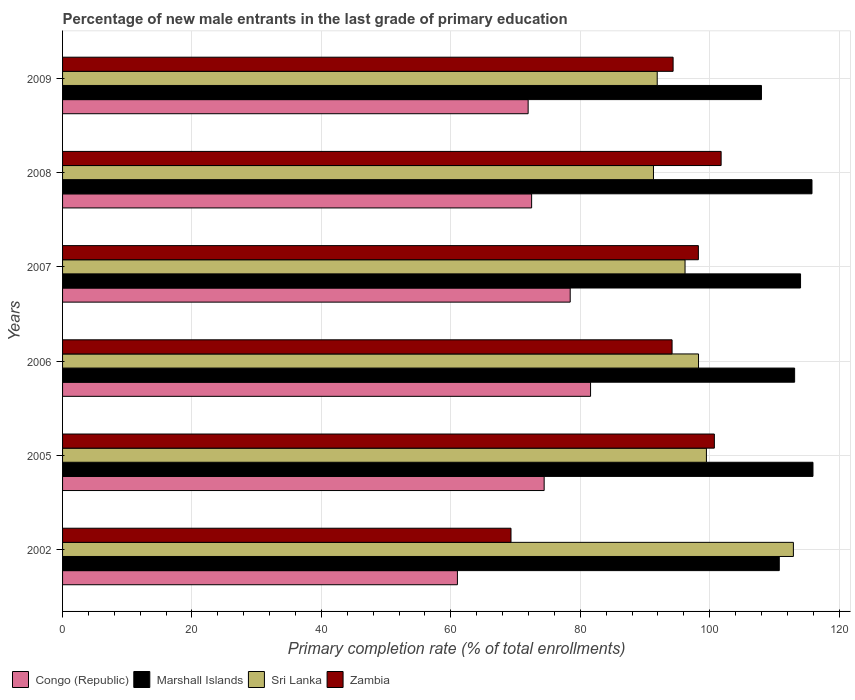How many different coloured bars are there?
Give a very brief answer. 4. Are the number of bars on each tick of the Y-axis equal?
Your response must be concise. Yes. How many bars are there on the 2nd tick from the bottom?
Make the answer very short. 4. In how many cases, is the number of bars for a given year not equal to the number of legend labels?
Your response must be concise. 0. What is the percentage of new male entrants in Zambia in 2009?
Your response must be concise. 94.35. Across all years, what is the maximum percentage of new male entrants in Congo (Republic)?
Offer a very short reply. 81.59. Across all years, what is the minimum percentage of new male entrants in Marshall Islands?
Make the answer very short. 108. In which year was the percentage of new male entrants in Zambia maximum?
Offer a terse response. 2008. In which year was the percentage of new male entrants in Sri Lanka minimum?
Your response must be concise. 2008. What is the total percentage of new male entrants in Sri Lanka in the graph?
Keep it short and to the point. 590.11. What is the difference between the percentage of new male entrants in Zambia in 2005 and that in 2007?
Keep it short and to the point. 2.47. What is the difference between the percentage of new male entrants in Marshall Islands in 2005 and the percentage of new male entrants in Zambia in 2008?
Make the answer very short. 14.19. What is the average percentage of new male entrants in Marshall Islands per year?
Keep it short and to the point. 112.95. In the year 2006, what is the difference between the percentage of new male entrants in Congo (Republic) and percentage of new male entrants in Sri Lanka?
Keep it short and to the point. -16.68. In how many years, is the percentage of new male entrants in Congo (Republic) greater than 116 %?
Your answer should be compact. 0. What is the ratio of the percentage of new male entrants in Congo (Republic) in 2005 to that in 2009?
Offer a very short reply. 1.03. What is the difference between the highest and the second highest percentage of new male entrants in Zambia?
Provide a succinct answer. 1.05. What is the difference between the highest and the lowest percentage of new male entrants in Zambia?
Your answer should be compact. 32.47. In how many years, is the percentage of new male entrants in Congo (Republic) greater than the average percentage of new male entrants in Congo (Republic) taken over all years?
Ensure brevity in your answer.  3. Is the sum of the percentage of new male entrants in Marshall Islands in 2002 and 2005 greater than the maximum percentage of new male entrants in Congo (Republic) across all years?
Give a very brief answer. Yes. What does the 3rd bar from the top in 2007 represents?
Your response must be concise. Marshall Islands. What does the 1st bar from the bottom in 2002 represents?
Make the answer very short. Congo (Republic). Is it the case that in every year, the sum of the percentage of new male entrants in Sri Lanka and percentage of new male entrants in Marshall Islands is greater than the percentage of new male entrants in Zambia?
Give a very brief answer. Yes. How many bars are there?
Provide a short and direct response. 24. How many years are there in the graph?
Give a very brief answer. 6. What is the difference between two consecutive major ticks on the X-axis?
Make the answer very short. 20. Are the values on the major ticks of X-axis written in scientific E-notation?
Your answer should be compact. No. Does the graph contain any zero values?
Provide a succinct answer. No. What is the title of the graph?
Give a very brief answer. Percentage of new male entrants in the last grade of primary education. What is the label or title of the X-axis?
Provide a short and direct response. Primary completion rate (% of total enrollments). What is the label or title of the Y-axis?
Make the answer very short. Years. What is the Primary completion rate (% of total enrollments) of Congo (Republic) in 2002?
Make the answer very short. 61.02. What is the Primary completion rate (% of total enrollments) of Marshall Islands in 2002?
Keep it short and to the point. 110.76. What is the Primary completion rate (% of total enrollments) of Sri Lanka in 2002?
Give a very brief answer. 112.94. What is the Primary completion rate (% of total enrollments) of Zambia in 2002?
Your answer should be compact. 69.3. What is the Primary completion rate (% of total enrollments) of Congo (Republic) in 2005?
Provide a short and direct response. 74.42. What is the Primary completion rate (% of total enrollments) in Marshall Islands in 2005?
Make the answer very short. 115.96. What is the Primary completion rate (% of total enrollments) of Sri Lanka in 2005?
Make the answer very short. 99.5. What is the Primary completion rate (% of total enrollments) in Zambia in 2005?
Provide a short and direct response. 100.72. What is the Primary completion rate (% of total enrollments) in Congo (Republic) in 2006?
Offer a very short reply. 81.59. What is the Primary completion rate (% of total enrollments) in Marshall Islands in 2006?
Your answer should be very brief. 113.13. What is the Primary completion rate (% of total enrollments) in Sri Lanka in 2006?
Keep it short and to the point. 98.27. What is the Primary completion rate (% of total enrollments) of Zambia in 2006?
Give a very brief answer. 94.19. What is the Primary completion rate (% of total enrollments) in Congo (Republic) in 2007?
Your response must be concise. 78.45. What is the Primary completion rate (% of total enrollments) of Marshall Islands in 2007?
Give a very brief answer. 114.04. What is the Primary completion rate (% of total enrollments) of Sri Lanka in 2007?
Provide a succinct answer. 96.19. What is the Primary completion rate (% of total enrollments) in Zambia in 2007?
Ensure brevity in your answer.  98.25. What is the Primary completion rate (% of total enrollments) of Congo (Republic) in 2008?
Provide a succinct answer. 72.48. What is the Primary completion rate (% of total enrollments) in Marshall Islands in 2008?
Give a very brief answer. 115.81. What is the Primary completion rate (% of total enrollments) of Sri Lanka in 2008?
Ensure brevity in your answer.  91.31. What is the Primary completion rate (% of total enrollments) of Zambia in 2008?
Offer a terse response. 101.77. What is the Primary completion rate (% of total enrollments) in Congo (Republic) in 2009?
Make the answer very short. 71.94. What is the Primary completion rate (% of total enrollments) of Marshall Islands in 2009?
Your response must be concise. 108. What is the Primary completion rate (% of total enrollments) in Sri Lanka in 2009?
Give a very brief answer. 91.89. What is the Primary completion rate (% of total enrollments) in Zambia in 2009?
Provide a succinct answer. 94.35. Across all years, what is the maximum Primary completion rate (% of total enrollments) of Congo (Republic)?
Provide a short and direct response. 81.59. Across all years, what is the maximum Primary completion rate (% of total enrollments) in Marshall Islands?
Ensure brevity in your answer.  115.96. Across all years, what is the maximum Primary completion rate (% of total enrollments) of Sri Lanka?
Your answer should be compact. 112.94. Across all years, what is the maximum Primary completion rate (% of total enrollments) in Zambia?
Offer a very short reply. 101.77. Across all years, what is the minimum Primary completion rate (% of total enrollments) in Congo (Republic)?
Your answer should be compact. 61.02. Across all years, what is the minimum Primary completion rate (% of total enrollments) of Marshall Islands?
Offer a terse response. 108. Across all years, what is the minimum Primary completion rate (% of total enrollments) of Sri Lanka?
Offer a very short reply. 91.31. Across all years, what is the minimum Primary completion rate (% of total enrollments) in Zambia?
Ensure brevity in your answer.  69.3. What is the total Primary completion rate (% of total enrollments) in Congo (Republic) in the graph?
Ensure brevity in your answer.  439.91. What is the total Primary completion rate (% of total enrollments) of Marshall Islands in the graph?
Make the answer very short. 677.7. What is the total Primary completion rate (% of total enrollments) in Sri Lanka in the graph?
Provide a succinct answer. 590.11. What is the total Primary completion rate (% of total enrollments) in Zambia in the graph?
Your answer should be compact. 558.58. What is the difference between the Primary completion rate (% of total enrollments) of Congo (Republic) in 2002 and that in 2005?
Your answer should be compact. -13.4. What is the difference between the Primary completion rate (% of total enrollments) of Marshall Islands in 2002 and that in 2005?
Keep it short and to the point. -5.21. What is the difference between the Primary completion rate (% of total enrollments) of Sri Lanka in 2002 and that in 2005?
Your answer should be very brief. 13.44. What is the difference between the Primary completion rate (% of total enrollments) of Zambia in 2002 and that in 2005?
Keep it short and to the point. -31.43. What is the difference between the Primary completion rate (% of total enrollments) in Congo (Republic) in 2002 and that in 2006?
Keep it short and to the point. -20.58. What is the difference between the Primary completion rate (% of total enrollments) in Marshall Islands in 2002 and that in 2006?
Keep it short and to the point. -2.37. What is the difference between the Primary completion rate (% of total enrollments) of Sri Lanka in 2002 and that in 2006?
Offer a very short reply. 14.66. What is the difference between the Primary completion rate (% of total enrollments) of Zambia in 2002 and that in 2006?
Provide a short and direct response. -24.89. What is the difference between the Primary completion rate (% of total enrollments) in Congo (Republic) in 2002 and that in 2007?
Your answer should be compact. -17.43. What is the difference between the Primary completion rate (% of total enrollments) of Marshall Islands in 2002 and that in 2007?
Your answer should be very brief. -3.29. What is the difference between the Primary completion rate (% of total enrollments) in Sri Lanka in 2002 and that in 2007?
Offer a terse response. 16.74. What is the difference between the Primary completion rate (% of total enrollments) in Zambia in 2002 and that in 2007?
Provide a succinct answer. -28.96. What is the difference between the Primary completion rate (% of total enrollments) of Congo (Republic) in 2002 and that in 2008?
Your answer should be compact. -11.47. What is the difference between the Primary completion rate (% of total enrollments) in Marshall Islands in 2002 and that in 2008?
Offer a very short reply. -5.05. What is the difference between the Primary completion rate (% of total enrollments) in Sri Lanka in 2002 and that in 2008?
Offer a very short reply. 21.62. What is the difference between the Primary completion rate (% of total enrollments) of Zambia in 2002 and that in 2008?
Keep it short and to the point. -32.47. What is the difference between the Primary completion rate (% of total enrollments) of Congo (Republic) in 2002 and that in 2009?
Offer a terse response. -10.93. What is the difference between the Primary completion rate (% of total enrollments) of Marshall Islands in 2002 and that in 2009?
Your response must be concise. 2.76. What is the difference between the Primary completion rate (% of total enrollments) of Sri Lanka in 2002 and that in 2009?
Ensure brevity in your answer.  21.04. What is the difference between the Primary completion rate (% of total enrollments) in Zambia in 2002 and that in 2009?
Provide a succinct answer. -25.05. What is the difference between the Primary completion rate (% of total enrollments) of Congo (Republic) in 2005 and that in 2006?
Offer a terse response. -7.17. What is the difference between the Primary completion rate (% of total enrollments) in Marshall Islands in 2005 and that in 2006?
Ensure brevity in your answer.  2.83. What is the difference between the Primary completion rate (% of total enrollments) in Sri Lanka in 2005 and that in 2006?
Provide a short and direct response. 1.22. What is the difference between the Primary completion rate (% of total enrollments) in Zambia in 2005 and that in 2006?
Your response must be concise. 6.54. What is the difference between the Primary completion rate (% of total enrollments) in Congo (Republic) in 2005 and that in 2007?
Offer a very short reply. -4.03. What is the difference between the Primary completion rate (% of total enrollments) of Marshall Islands in 2005 and that in 2007?
Provide a short and direct response. 1.92. What is the difference between the Primary completion rate (% of total enrollments) of Sri Lanka in 2005 and that in 2007?
Your response must be concise. 3.3. What is the difference between the Primary completion rate (% of total enrollments) of Zambia in 2005 and that in 2007?
Offer a terse response. 2.47. What is the difference between the Primary completion rate (% of total enrollments) of Congo (Republic) in 2005 and that in 2008?
Your answer should be very brief. 1.94. What is the difference between the Primary completion rate (% of total enrollments) in Marshall Islands in 2005 and that in 2008?
Your answer should be very brief. 0.15. What is the difference between the Primary completion rate (% of total enrollments) in Sri Lanka in 2005 and that in 2008?
Provide a short and direct response. 8.18. What is the difference between the Primary completion rate (% of total enrollments) in Zambia in 2005 and that in 2008?
Your answer should be compact. -1.05. What is the difference between the Primary completion rate (% of total enrollments) in Congo (Republic) in 2005 and that in 2009?
Provide a short and direct response. 2.48. What is the difference between the Primary completion rate (% of total enrollments) of Marshall Islands in 2005 and that in 2009?
Keep it short and to the point. 7.96. What is the difference between the Primary completion rate (% of total enrollments) in Sri Lanka in 2005 and that in 2009?
Make the answer very short. 7.6. What is the difference between the Primary completion rate (% of total enrollments) of Zambia in 2005 and that in 2009?
Provide a succinct answer. 6.38. What is the difference between the Primary completion rate (% of total enrollments) in Congo (Republic) in 2006 and that in 2007?
Offer a very short reply. 3.15. What is the difference between the Primary completion rate (% of total enrollments) in Marshall Islands in 2006 and that in 2007?
Your answer should be compact. -0.91. What is the difference between the Primary completion rate (% of total enrollments) in Sri Lanka in 2006 and that in 2007?
Give a very brief answer. 2.08. What is the difference between the Primary completion rate (% of total enrollments) of Zambia in 2006 and that in 2007?
Ensure brevity in your answer.  -4.07. What is the difference between the Primary completion rate (% of total enrollments) in Congo (Republic) in 2006 and that in 2008?
Give a very brief answer. 9.11. What is the difference between the Primary completion rate (% of total enrollments) in Marshall Islands in 2006 and that in 2008?
Provide a short and direct response. -2.68. What is the difference between the Primary completion rate (% of total enrollments) of Sri Lanka in 2006 and that in 2008?
Your answer should be compact. 6.96. What is the difference between the Primary completion rate (% of total enrollments) of Zambia in 2006 and that in 2008?
Provide a short and direct response. -7.58. What is the difference between the Primary completion rate (% of total enrollments) of Congo (Republic) in 2006 and that in 2009?
Your response must be concise. 9.65. What is the difference between the Primary completion rate (% of total enrollments) of Marshall Islands in 2006 and that in 2009?
Ensure brevity in your answer.  5.13. What is the difference between the Primary completion rate (% of total enrollments) of Sri Lanka in 2006 and that in 2009?
Give a very brief answer. 6.38. What is the difference between the Primary completion rate (% of total enrollments) of Zambia in 2006 and that in 2009?
Provide a succinct answer. -0.16. What is the difference between the Primary completion rate (% of total enrollments) in Congo (Republic) in 2007 and that in 2008?
Provide a succinct answer. 5.96. What is the difference between the Primary completion rate (% of total enrollments) of Marshall Islands in 2007 and that in 2008?
Offer a terse response. -1.77. What is the difference between the Primary completion rate (% of total enrollments) in Sri Lanka in 2007 and that in 2008?
Offer a terse response. 4.88. What is the difference between the Primary completion rate (% of total enrollments) in Zambia in 2007 and that in 2008?
Your response must be concise. -3.52. What is the difference between the Primary completion rate (% of total enrollments) of Congo (Republic) in 2007 and that in 2009?
Ensure brevity in your answer.  6.5. What is the difference between the Primary completion rate (% of total enrollments) in Marshall Islands in 2007 and that in 2009?
Your answer should be very brief. 6.04. What is the difference between the Primary completion rate (% of total enrollments) of Sri Lanka in 2007 and that in 2009?
Offer a terse response. 4.3. What is the difference between the Primary completion rate (% of total enrollments) in Zambia in 2007 and that in 2009?
Your response must be concise. 3.91. What is the difference between the Primary completion rate (% of total enrollments) of Congo (Republic) in 2008 and that in 2009?
Give a very brief answer. 0.54. What is the difference between the Primary completion rate (% of total enrollments) in Marshall Islands in 2008 and that in 2009?
Your response must be concise. 7.81. What is the difference between the Primary completion rate (% of total enrollments) in Sri Lanka in 2008 and that in 2009?
Your answer should be compact. -0.58. What is the difference between the Primary completion rate (% of total enrollments) of Zambia in 2008 and that in 2009?
Your answer should be very brief. 7.42. What is the difference between the Primary completion rate (% of total enrollments) of Congo (Republic) in 2002 and the Primary completion rate (% of total enrollments) of Marshall Islands in 2005?
Your response must be concise. -54.94. What is the difference between the Primary completion rate (% of total enrollments) in Congo (Republic) in 2002 and the Primary completion rate (% of total enrollments) in Sri Lanka in 2005?
Provide a short and direct response. -38.48. What is the difference between the Primary completion rate (% of total enrollments) in Congo (Republic) in 2002 and the Primary completion rate (% of total enrollments) in Zambia in 2005?
Give a very brief answer. -39.71. What is the difference between the Primary completion rate (% of total enrollments) in Marshall Islands in 2002 and the Primary completion rate (% of total enrollments) in Sri Lanka in 2005?
Make the answer very short. 11.26. What is the difference between the Primary completion rate (% of total enrollments) in Marshall Islands in 2002 and the Primary completion rate (% of total enrollments) in Zambia in 2005?
Ensure brevity in your answer.  10.03. What is the difference between the Primary completion rate (% of total enrollments) in Sri Lanka in 2002 and the Primary completion rate (% of total enrollments) in Zambia in 2005?
Your response must be concise. 12.21. What is the difference between the Primary completion rate (% of total enrollments) in Congo (Republic) in 2002 and the Primary completion rate (% of total enrollments) in Marshall Islands in 2006?
Your response must be concise. -52.11. What is the difference between the Primary completion rate (% of total enrollments) in Congo (Republic) in 2002 and the Primary completion rate (% of total enrollments) in Sri Lanka in 2006?
Ensure brevity in your answer.  -37.26. What is the difference between the Primary completion rate (% of total enrollments) of Congo (Republic) in 2002 and the Primary completion rate (% of total enrollments) of Zambia in 2006?
Keep it short and to the point. -33.17. What is the difference between the Primary completion rate (% of total enrollments) in Marshall Islands in 2002 and the Primary completion rate (% of total enrollments) in Sri Lanka in 2006?
Ensure brevity in your answer.  12.48. What is the difference between the Primary completion rate (% of total enrollments) of Marshall Islands in 2002 and the Primary completion rate (% of total enrollments) of Zambia in 2006?
Your answer should be very brief. 16.57. What is the difference between the Primary completion rate (% of total enrollments) in Sri Lanka in 2002 and the Primary completion rate (% of total enrollments) in Zambia in 2006?
Your answer should be very brief. 18.75. What is the difference between the Primary completion rate (% of total enrollments) in Congo (Republic) in 2002 and the Primary completion rate (% of total enrollments) in Marshall Islands in 2007?
Ensure brevity in your answer.  -53.02. What is the difference between the Primary completion rate (% of total enrollments) of Congo (Republic) in 2002 and the Primary completion rate (% of total enrollments) of Sri Lanka in 2007?
Your answer should be very brief. -35.18. What is the difference between the Primary completion rate (% of total enrollments) of Congo (Republic) in 2002 and the Primary completion rate (% of total enrollments) of Zambia in 2007?
Offer a very short reply. -37.24. What is the difference between the Primary completion rate (% of total enrollments) in Marshall Islands in 2002 and the Primary completion rate (% of total enrollments) in Sri Lanka in 2007?
Your response must be concise. 14.56. What is the difference between the Primary completion rate (% of total enrollments) of Marshall Islands in 2002 and the Primary completion rate (% of total enrollments) of Zambia in 2007?
Give a very brief answer. 12.5. What is the difference between the Primary completion rate (% of total enrollments) in Sri Lanka in 2002 and the Primary completion rate (% of total enrollments) in Zambia in 2007?
Make the answer very short. 14.68. What is the difference between the Primary completion rate (% of total enrollments) of Congo (Republic) in 2002 and the Primary completion rate (% of total enrollments) of Marshall Islands in 2008?
Your answer should be compact. -54.79. What is the difference between the Primary completion rate (% of total enrollments) of Congo (Republic) in 2002 and the Primary completion rate (% of total enrollments) of Sri Lanka in 2008?
Ensure brevity in your answer.  -30.3. What is the difference between the Primary completion rate (% of total enrollments) in Congo (Republic) in 2002 and the Primary completion rate (% of total enrollments) in Zambia in 2008?
Keep it short and to the point. -40.75. What is the difference between the Primary completion rate (% of total enrollments) of Marshall Islands in 2002 and the Primary completion rate (% of total enrollments) of Sri Lanka in 2008?
Make the answer very short. 19.44. What is the difference between the Primary completion rate (% of total enrollments) in Marshall Islands in 2002 and the Primary completion rate (% of total enrollments) in Zambia in 2008?
Provide a short and direct response. 8.99. What is the difference between the Primary completion rate (% of total enrollments) of Sri Lanka in 2002 and the Primary completion rate (% of total enrollments) of Zambia in 2008?
Provide a succinct answer. 11.17. What is the difference between the Primary completion rate (% of total enrollments) of Congo (Republic) in 2002 and the Primary completion rate (% of total enrollments) of Marshall Islands in 2009?
Your response must be concise. -46.98. What is the difference between the Primary completion rate (% of total enrollments) in Congo (Republic) in 2002 and the Primary completion rate (% of total enrollments) in Sri Lanka in 2009?
Your answer should be compact. -30.88. What is the difference between the Primary completion rate (% of total enrollments) in Congo (Republic) in 2002 and the Primary completion rate (% of total enrollments) in Zambia in 2009?
Give a very brief answer. -33.33. What is the difference between the Primary completion rate (% of total enrollments) in Marshall Islands in 2002 and the Primary completion rate (% of total enrollments) in Sri Lanka in 2009?
Make the answer very short. 18.86. What is the difference between the Primary completion rate (% of total enrollments) in Marshall Islands in 2002 and the Primary completion rate (% of total enrollments) in Zambia in 2009?
Keep it short and to the point. 16.41. What is the difference between the Primary completion rate (% of total enrollments) of Sri Lanka in 2002 and the Primary completion rate (% of total enrollments) of Zambia in 2009?
Provide a short and direct response. 18.59. What is the difference between the Primary completion rate (% of total enrollments) of Congo (Republic) in 2005 and the Primary completion rate (% of total enrollments) of Marshall Islands in 2006?
Offer a terse response. -38.71. What is the difference between the Primary completion rate (% of total enrollments) in Congo (Republic) in 2005 and the Primary completion rate (% of total enrollments) in Sri Lanka in 2006?
Provide a succinct answer. -23.85. What is the difference between the Primary completion rate (% of total enrollments) in Congo (Republic) in 2005 and the Primary completion rate (% of total enrollments) in Zambia in 2006?
Give a very brief answer. -19.77. What is the difference between the Primary completion rate (% of total enrollments) of Marshall Islands in 2005 and the Primary completion rate (% of total enrollments) of Sri Lanka in 2006?
Your answer should be very brief. 17.69. What is the difference between the Primary completion rate (% of total enrollments) in Marshall Islands in 2005 and the Primary completion rate (% of total enrollments) in Zambia in 2006?
Make the answer very short. 21.77. What is the difference between the Primary completion rate (% of total enrollments) in Sri Lanka in 2005 and the Primary completion rate (% of total enrollments) in Zambia in 2006?
Your answer should be compact. 5.31. What is the difference between the Primary completion rate (% of total enrollments) of Congo (Republic) in 2005 and the Primary completion rate (% of total enrollments) of Marshall Islands in 2007?
Offer a very short reply. -39.62. What is the difference between the Primary completion rate (% of total enrollments) of Congo (Republic) in 2005 and the Primary completion rate (% of total enrollments) of Sri Lanka in 2007?
Offer a very short reply. -21.77. What is the difference between the Primary completion rate (% of total enrollments) in Congo (Republic) in 2005 and the Primary completion rate (% of total enrollments) in Zambia in 2007?
Your answer should be very brief. -23.83. What is the difference between the Primary completion rate (% of total enrollments) in Marshall Islands in 2005 and the Primary completion rate (% of total enrollments) in Sri Lanka in 2007?
Keep it short and to the point. 19.77. What is the difference between the Primary completion rate (% of total enrollments) of Marshall Islands in 2005 and the Primary completion rate (% of total enrollments) of Zambia in 2007?
Your answer should be compact. 17.71. What is the difference between the Primary completion rate (% of total enrollments) of Sri Lanka in 2005 and the Primary completion rate (% of total enrollments) of Zambia in 2007?
Keep it short and to the point. 1.24. What is the difference between the Primary completion rate (% of total enrollments) of Congo (Republic) in 2005 and the Primary completion rate (% of total enrollments) of Marshall Islands in 2008?
Provide a short and direct response. -41.39. What is the difference between the Primary completion rate (% of total enrollments) of Congo (Republic) in 2005 and the Primary completion rate (% of total enrollments) of Sri Lanka in 2008?
Provide a short and direct response. -16.89. What is the difference between the Primary completion rate (% of total enrollments) in Congo (Republic) in 2005 and the Primary completion rate (% of total enrollments) in Zambia in 2008?
Make the answer very short. -27.35. What is the difference between the Primary completion rate (% of total enrollments) in Marshall Islands in 2005 and the Primary completion rate (% of total enrollments) in Sri Lanka in 2008?
Your answer should be compact. 24.65. What is the difference between the Primary completion rate (% of total enrollments) of Marshall Islands in 2005 and the Primary completion rate (% of total enrollments) of Zambia in 2008?
Your response must be concise. 14.19. What is the difference between the Primary completion rate (% of total enrollments) of Sri Lanka in 2005 and the Primary completion rate (% of total enrollments) of Zambia in 2008?
Keep it short and to the point. -2.27. What is the difference between the Primary completion rate (% of total enrollments) of Congo (Republic) in 2005 and the Primary completion rate (% of total enrollments) of Marshall Islands in 2009?
Offer a terse response. -33.58. What is the difference between the Primary completion rate (% of total enrollments) of Congo (Republic) in 2005 and the Primary completion rate (% of total enrollments) of Sri Lanka in 2009?
Provide a succinct answer. -17.47. What is the difference between the Primary completion rate (% of total enrollments) in Congo (Republic) in 2005 and the Primary completion rate (% of total enrollments) in Zambia in 2009?
Offer a terse response. -19.93. What is the difference between the Primary completion rate (% of total enrollments) in Marshall Islands in 2005 and the Primary completion rate (% of total enrollments) in Sri Lanka in 2009?
Ensure brevity in your answer.  24.07. What is the difference between the Primary completion rate (% of total enrollments) in Marshall Islands in 2005 and the Primary completion rate (% of total enrollments) in Zambia in 2009?
Ensure brevity in your answer.  21.61. What is the difference between the Primary completion rate (% of total enrollments) in Sri Lanka in 2005 and the Primary completion rate (% of total enrollments) in Zambia in 2009?
Give a very brief answer. 5.15. What is the difference between the Primary completion rate (% of total enrollments) of Congo (Republic) in 2006 and the Primary completion rate (% of total enrollments) of Marshall Islands in 2007?
Provide a succinct answer. -32.45. What is the difference between the Primary completion rate (% of total enrollments) of Congo (Republic) in 2006 and the Primary completion rate (% of total enrollments) of Sri Lanka in 2007?
Make the answer very short. -14.6. What is the difference between the Primary completion rate (% of total enrollments) in Congo (Republic) in 2006 and the Primary completion rate (% of total enrollments) in Zambia in 2007?
Ensure brevity in your answer.  -16.66. What is the difference between the Primary completion rate (% of total enrollments) of Marshall Islands in 2006 and the Primary completion rate (% of total enrollments) of Sri Lanka in 2007?
Provide a short and direct response. 16.93. What is the difference between the Primary completion rate (% of total enrollments) of Marshall Islands in 2006 and the Primary completion rate (% of total enrollments) of Zambia in 2007?
Offer a terse response. 14.87. What is the difference between the Primary completion rate (% of total enrollments) of Sri Lanka in 2006 and the Primary completion rate (% of total enrollments) of Zambia in 2007?
Make the answer very short. 0.02. What is the difference between the Primary completion rate (% of total enrollments) of Congo (Republic) in 2006 and the Primary completion rate (% of total enrollments) of Marshall Islands in 2008?
Ensure brevity in your answer.  -34.22. What is the difference between the Primary completion rate (% of total enrollments) in Congo (Republic) in 2006 and the Primary completion rate (% of total enrollments) in Sri Lanka in 2008?
Provide a succinct answer. -9.72. What is the difference between the Primary completion rate (% of total enrollments) of Congo (Republic) in 2006 and the Primary completion rate (% of total enrollments) of Zambia in 2008?
Provide a succinct answer. -20.18. What is the difference between the Primary completion rate (% of total enrollments) of Marshall Islands in 2006 and the Primary completion rate (% of total enrollments) of Sri Lanka in 2008?
Your answer should be compact. 21.81. What is the difference between the Primary completion rate (% of total enrollments) in Marshall Islands in 2006 and the Primary completion rate (% of total enrollments) in Zambia in 2008?
Provide a short and direct response. 11.36. What is the difference between the Primary completion rate (% of total enrollments) of Sri Lanka in 2006 and the Primary completion rate (% of total enrollments) of Zambia in 2008?
Your answer should be very brief. -3.49. What is the difference between the Primary completion rate (% of total enrollments) in Congo (Republic) in 2006 and the Primary completion rate (% of total enrollments) in Marshall Islands in 2009?
Offer a terse response. -26.41. What is the difference between the Primary completion rate (% of total enrollments) in Congo (Republic) in 2006 and the Primary completion rate (% of total enrollments) in Sri Lanka in 2009?
Offer a very short reply. -10.3. What is the difference between the Primary completion rate (% of total enrollments) of Congo (Republic) in 2006 and the Primary completion rate (% of total enrollments) of Zambia in 2009?
Offer a very short reply. -12.76. What is the difference between the Primary completion rate (% of total enrollments) in Marshall Islands in 2006 and the Primary completion rate (% of total enrollments) in Sri Lanka in 2009?
Make the answer very short. 21.23. What is the difference between the Primary completion rate (% of total enrollments) of Marshall Islands in 2006 and the Primary completion rate (% of total enrollments) of Zambia in 2009?
Provide a short and direct response. 18.78. What is the difference between the Primary completion rate (% of total enrollments) in Sri Lanka in 2006 and the Primary completion rate (% of total enrollments) in Zambia in 2009?
Ensure brevity in your answer.  3.93. What is the difference between the Primary completion rate (% of total enrollments) of Congo (Republic) in 2007 and the Primary completion rate (% of total enrollments) of Marshall Islands in 2008?
Your answer should be very brief. -37.36. What is the difference between the Primary completion rate (% of total enrollments) of Congo (Republic) in 2007 and the Primary completion rate (% of total enrollments) of Sri Lanka in 2008?
Keep it short and to the point. -12.87. What is the difference between the Primary completion rate (% of total enrollments) of Congo (Republic) in 2007 and the Primary completion rate (% of total enrollments) of Zambia in 2008?
Provide a succinct answer. -23.32. What is the difference between the Primary completion rate (% of total enrollments) of Marshall Islands in 2007 and the Primary completion rate (% of total enrollments) of Sri Lanka in 2008?
Provide a succinct answer. 22.73. What is the difference between the Primary completion rate (% of total enrollments) of Marshall Islands in 2007 and the Primary completion rate (% of total enrollments) of Zambia in 2008?
Ensure brevity in your answer.  12.27. What is the difference between the Primary completion rate (% of total enrollments) of Sri Lanka in 2007 and the Primary completion rate (% of total enrollments) of Zambia in 2008?
Keep it short and to the point. -5.58. What is the difference between the Primary completion rate (% of total enrollments) in Congo (Republic) in 2007 and the Primary completion rate (% of total enrollments) in Marshall Islands in 2009?
Make the answer very short. -29.55. What is the difference between the Primary completion rate (% of total enrollments) of Congo (Republic) in 2007 and the Primary completion rate (% of total enrollments) of Sri Lanka in 2009?
Your answer should be compact. -13.45. What is the difference between the Primary completion rate (% of total enrollments) of Congo (Republic) in 2007 and the Primary completion rate (% of total enrollments) of Zambia in 2009?
Give a very brief answer. -15.9. What is the difference between the Primary completion rate (% of total enrollments) in Marshall Islands in 2007 and the Primary completion rate (% of total enrollments) in Sri Lanka in 2009?
Your answer should be compact. 22.15. What is the difference between the Primary completion rate (% of total enrollments) of Marshall Islands in 2007 and the Primary completion rate (% of total enrollments) of Zambia in 2009?
Your response must be concise. 19.69. What is the difference between the Primary completion rate (% of total enrollments) of Sri Lanka in 2007 and the Primary completion rate (% of total enrollments) of Zambia in 2009?
Provide a short and direct response. 1.84. What is the difference between the Primary completion rate (% of total enrollments) in Congo (Republic) in 2008 and the Primary completion rate (% of total enrollments) in Marshall Islands in 2009?
Make the answer very short. -35.52. What is the difference between the Primary completion rate (% of total enrollments) in Congo (Republic) in 2008 and the Primary completion rate (% of total enrollments) in Sri Lanka in 2009?
Offer a terse response. -19.41. What is the difference between the Primary completion rate (% of total enrollments) in Congo (Republic) in 2008 and the Primary completion rate (% of total enrollments) in Zambia in 2009?
Your answer should be compact. -21.86. What is the difference between the Primary completion rate (% of total enrollments) in Marshall Islands in 2008 and the Primary completion rate (% of total enrollments) in Sri Lanka in 2009?
Ensure brevity in your answer.  23.92. What is the difference between the Primary completion rate (% of total enrollments) in Marshall Islands in 2008 and the Primary completion rate (% of total enrollments) in Zambia in 2009?
Your response must be concise. 21.46. What is the difference between the Primary completion rate (% of total enrollments) in Sri Lanka in 2008 and the Primary completion rate (% of total enrollments) in Zambia in 2009?
Your answer should be compact. -3.04. What is the average Primary completion rate (% of total enrollments) of Congo (Republic) per year?
Your answer should be compact. 73.32. What is the average Primary completion rate (% of total enrollments) of Marshall Islands per year?
Keep it short and to the point. 112.95. What is the average Primary completion rate (% of total enrollments) in Sri Lanka per year?
Provide a short and direct response. 98.35. What is the average Primary completion rate (% of total enrollments) of Zambia per year?
Make the answer very short. 93.1. In the year 2002, what is the difference between the Primary completion rate (% of total enrollments) of Congo (Republic) and Primary completion rate (% of total enrollments) of Marshall Islands?
Provide a succinct answer. -49.74. In the year 2002, what is the difference between the Primary completion rate (% of total enrollments) in Congo (Republic) and Primary completion rate (% of total enrollments) in Sri Lanka?
Provide a short and direct response. -51.92. In the year 2002, what is the difference between the Primary completion rate (% of total enrollments) of Congo (Republic) and Primary completion rate (% of total enrollments) of Zambia?
Keep it short and to the point. -8.28. In the year 2002, what is the difference between the Primary completion rate (% of total enrollments) in Marshall Islands and Primary completion rate (% of total enrollments) in Sri Lanka?
Your response must be concise. -2.18. In the year 2002, what is the difference between the Primary completion rate (% of total enrollments) in Marshall Islands and Primary completion rate (% of total enrollments) in Zambia?
Ensure brevity in your answer.  41.46. In the year 2002, what is the difference between the Primary completion rate (% of total enrollments) in Sri Lanka and Primary completion rate (% of total enrollments) in Zambia?
Offer a very short reply. 43.64. In the year 2005, what is the difference between the Primary completion rate (% of total enrollments) in Congo (Republic) and Primary completion rate (% of total enrollments) in Marshall Islands?
Your answer should be very brief. -41.54. In the year 2005, what is the difference between the Primary completion rate (% of total enrollments) of Congo (Republic) and Primary completion rate (% of total enrollments) of Sri Lanka?
Offer a terse response. -25.08. In the year 2005, what is the difference between the Primary completion rate (% of total enrollments) of Congo (Republic) and Primary completion rate (% of total enrollments) of Zambia?
Keep it short and to the point. -26.3. In the year 2005, what is the difference between the Primary completion rate (% of total enrollments) of Marshall Islands and Primary completion rate (% of total enrollments) of Sri Lanka?
Your response must be concise. 16.46. In the year 2005, what is the difference between the Primary completion rate (% of total enrollments) of Marshall Islands and Primary completion rate (% of total enrollments) of Zambia?
Your response must be concise. 15.24. In the year 2005, what is the difference between the Primary completion rate (% of total enrollments) of Sri Lanka and Primary completion rate (% of total enrollments) of Zambia?
Keep it short and to the point. -1.23. In the year 2006, what is the difference between the Primary completion rate (% of total enrollments) of Congo (Republic) and Primary completion rate (% of total enrollments) of Marshall Islands?
Provide a short and direct response. -31.53. In the year 2006, what is the difference between the Primary completion rate (% of total enrollments) of Congo (Republic) and Primary completion rate (% of total enrollments) of Sri Lanka?
Your answer should be very brief. -16.68. In the year 2006, what is the difference between the Primary completion rate (% of total enrollments) of Congo (Republic) and Primary completion rate (% of total enrollments) of Zambia?
Provide a succinct answer. -12.6. In the year 2006, what is the difference between the Primary completion rate (% of total enrollments) of Marshall Islands and Primary completion rate (% of total enrollments) of Sri Lanka?
Provide a short and direct response. 14.85. In the year 2006, what is the difference between the Primary completion rate (% of total enrollments) in Marshall Islands and Primary completion rate (% of total enrollments) in Zambia?
Ensure brevity in your answer.  18.94. In the year 2006, what is the difference between the Primary completion rate (% of total enrollments) of Sri Lanka and Primary completion rate (% of total enrollments) of Zambia?
Your answer should be very brief. 4.09. In the year 2007, what is the difference between the Primary completion rate (% of total enrollments) of Congo (Republic) and Primary completion rate (% of total enrollments) of Marshall Islands?
Offer a very short reply. -35.6. In the year 2007, what is the difference between the Primary completion rate (% of total enrollments) in Congo (Republic) and Primary completion rate (% of total enrollments) in Sri Lanka?
Ensure brevity in your answer.  -17.75. In the year 2007, what is the difference between the Primary completion rate (% of total enrollments) in Congo (Republic) and Primary completion rate (% of total enrollments) in Zambia?
Your answer should be very brief. -19.81. In the year 2007, what is the difference between the Primary completion rate (% of total enrollments) in Marshall Islands and Primary completion rate (% of total enrollments) in Sri Lanka?
Your response must be concise. 17.85. In the year 2007, what is the difference between the Primary completion rate (% of total enrollments) in Marshall Islands and Primary completion rate (% of total enrollments) in Zambia?
Make the answer very short. 15.79. In the year 2007, what is the difference between the Primary completion rate (% of total enrollments) of Sri Lanka and Primary completion rate (% of total enrollments) of Zambia?
Offer a very short reply. -2.06. In the year 2008, what is the difference between the Primary completion rate (% of total enrollments) in Congo (Republic) and Primary completion rate (% of total enrollments) in Marshall Islands?
Offer a very short reply. -43.32. In the year 2008, what is the difference between the Primary completion rate (% of total enrollments) of Congo (Republic) and Primary completion rate (% of total enrollments) of Sri Lanka?
Provide a succinct answer. -18.83. In the year 2008, what is the difference between the Primary completion rate (% of total enrollments) of Congo (Republic) and Primary completion rate (% of total enrollments) of Zambia?
Offer a terse response. -29.28. In the year 2008, what is the difference between the Primary completion rate (% of total enrollments) of Marshall Islands and Primary completion rate (% of total enrollments) of Sri Lanka?
Offer a very short reply. 24.5. In the year 2008, what is the difference between the Primary completion rate (% of total enrollments) of Marshall Islands and Primary completion rate (% of total enrollments) of Zambia?
Provide a succinct answer. 14.04. In the year 2008, what is the difference between the Primary completion rate (% of total enrollments) of Sri Lanka and Primary completion rate (% of total enrollments) of Zambia?
Your answer should be compact. -10.46. In the year 2009, what is the difference between the Primary completion rate (% of total enrollments) in Congo (Republic) and Primary completion rate (% of total enrollments) in Marshall Islands?
Provide a succinct answer. -36.05. In the year 2009, what is the difference between the Primary completion rate (% of total enrollments) of Congo (Republic) and Primary completion rate (% of total enrollments) of Sri Lanka?
Offer a very short reply. -19.95. In the year 2009, what is the difference between the Primary completion rate (% of total enrollments) in Congo (Republic) and Primary completion rate (% of total enrollments) in Zambia?
Offer a very short reply. -22.4. In the year 2009, what is the difference between the Primary completion rate (% of total enrollments) of Marshall Islands and Primary completion rate (% of total enrollments) of Sri Lanka?
Ensure brevity in your answer.  16.11. In the year 2009, what is the difference between the Primary completion rate (% of total enrollments) of Marshall Islands and Primary completion rate (% of total enrollments) of Zambia?
Provide a succinct answer. 13.65. In the year 2009, what is the difference between the Primary completion rate (% of total enrollments) in Sri Lanka and Primary completion rate (% of total enrollments) in Zambia?
Provide a short and direct response. -2.45. What is the ratio of the Primary completion rate (% of total enrollments) in Congo (Republic) in 2002 to that in 2005?
Keep it short and to the point. 0.82. What is the ratio of the Primary completion rate (% of total enrollments) in Marshall Islands in 2002 to that in 2005?
Give a very brief answer. 0.96. What is the ratio of the Primary completion rate (% of total enrollments) of Sri Lanka in 2002 to that in 2005?
Provide a succinct answer. 1.14. What is the ratio of the Primary completion rate (% of total enrollments) in Zambia in 2002 to that in 2005?
Provide a succinct answer. 0.69. What is the ratio of the Primary completion rate (% of total enrollments) of Congo (Republic) in 2002 to that in 2006?
Keep it short and to the point. 0.75. What is the ratio of the Primary completion rate (% of total enrollments) of Sri Lanka in 2002 to that in 2006?
Give a very brief answer. 1.15. What is the ratio of the Primary completion rate (% of total enrollments) in Zambia in 2002 to that in 2006?
Provide a short and direct response. 0.74. What is the ratio of the Primary completion rate (% of total enrollments) in Congo (Republic) in 2002 to that in 2007?
Your answer should be very brief. 0.78. What is the ratio of the Primary completion rate (% of total enrollments) of Marshall Islands in 2002 to that in 2007?
Provide a succinct answer. 0.97. What is the ratio of the Primary completion rate (% of total enrollments) of Sri Lanka in 2002 to that in 2007?
Offer a very short reply. 1.17. What is the ratio of the Primary completion rate (% of total enrollments) in Zambia in 2002 to that in 2007?
Keep it short and to the point. 0.71. What is the ratio of the Primary completion rate (% of total enrollments) in Congo (Republic) in 2002 to that in 2008?
Provide a short and direct response. 0.84. What is the ratio of the Primary completion rate (% of total enrollments) of Marshall Islands in 2002 to that in 2008?
Make the answer very short. 0.96. What is the ratio of the Primary completion rate (% of total enrollments) in Sri Lanka in 2002 to that in 2008?
Offer a terse response. 1.24. What is the ratio of the Primary completion rate (% of total enrollments) in Zambia in 2002 to that in 2008?
Your answer should be compact. 0.68. What is the ratio of the Primary completion rate (% of total enrollments) in Congo (Republic) in 2002 to that in 2009?
Give a very brief answer. 0.85. What is the ratio of the Primary completion rate (% of total enrollments) of Marshall Islands in 2002 to that in 2009?
Offer a very short reply. 1.03. What is the ratio of the Primary completion rate (% of total enrollments) in Sri Lanka in 2002 to that in 2009?
Make the answer very short. 1.23. What is the ratio of the Primary completion rate (% of total enrollments) in Zambia in 2002 to that in 2009?
Your answer should be compact. 0.73. What is the ratio of the Primary completion rate (% of total enrollments) in Congo (Republic) in 2005 to that in 2006?
Give a very brief answer. 0.91. What is the ratio of the Primary completion rate (% of total enrollments) in Marshall Islands in 2005 to that in 2006?
Give a very brief answer. 1.03. What is the ratio of the Primary completion rate (% of total enrollments) in Sri Lanka in 2005 to that in 2006?
Your answer should be compact. 1.01. What is the ratio of the Primary completion rate (% of total enrollments) of Zambia in 2005 to that in 2006?
Your answer should be compact. 1.07. What is the ratio of the Primary completion rate (% of total enrollments) of Congo (Republic) in 2005 to that in 2007?
Provide a short and direct response. 0.95. What is the ratio of the Primary completion rate (% of total enrollments) of Marshall Islands in 2005 to that in 2007?
Provide a succinct answer. 1.02. What is the ratio of the Primary completion rate (% of total enrollments) in Sri Lanka in 2005 to that in 2007?
Offer a very short reply. 1.03. What is the ratio of the Primary completion rate (% of total enrollments) in Zambia in 2005 to that in 2007?
Offer a very short reply. 1.03. What is the ratio of the Primary completion rate (% of total enrollments) in Congo (Republic) in 2005 to that in 2008?
Your response must be concise. 1.03. What is the ratio of the Primary completion rate (% of total enrollments) of Sri Lanka in 2005 to that in 2008?
Offer a terse response. 1.09. What is the ratio of the Primary completion rate (% of total enrollments) in Congo (Republic) in 2005 to that in 2009?
Offer a terse response. 1.03. What is the ratio of the Primary completion rate (% of total enrollments) of Marshall Islands in 2005 to that in 2009?
Your answer should be very brief. 1.07. What is the ratio of the Primary completion rate (% of total enrollments) of Sri Lanka in 2005 to that in 2009?
Your answer should be very brief. 1.08. What is the ratio of the Primary completion rate (% of total enrollments) of Zambia in 2005 to that in 2009?
Give a very brief answer. 1.07. What is the ratio of the Primary completion rate (% of total enrollments) of Congo (Republic) in 2006 to that in 2007?
Give a very brief answer. 1.04. What is the ratio of the Primary completion rate (% of total enrollments) in Sri Lanka in 2006 to that in 2007?
Make the answer very short. 1.02. What is the ratio of the Primary completion rate (% of total enrollments) of Zambia in 2006 to that in 2007?
Provide a short and direct response. 0.96. What is the ratio of the Primary completion rate (% of total enrollments) of Congo (Republic) in 2006 to that in 2008?
Offer a terse response. 1.13. What is the ratio of the Primary completion rate (% of total enrollments) of Marshall Islands in 2006 to that in 2008?
Provide a succinct answer. 0.98. What is the ratio of the Primary completion rate (% of total enrollments) in Sri Lanka in 2006 to that in 2008?
Ensure brevity in your answer.  1.08. What is the ratio of the Primary completion rate (% of total enrollments) in Zambia in 2006 to that in 2008?
Give a very brief answer. 0.93. What is the ratio of the Primary completion rate (% of total enrollments) of Congo (Republic) in 2006 to that in 2009?
Ensure brevity in your answer.  1.13. What is the ratio of the Primary completion rate (% of total enrollments) of Marshall Islands in 2006 to that in 2009?
Your response must be concise. 1.05. What is the ratio of the Primary completion rate (% of total enrollments) of Sri Lanka in 2006 to that in 2009?
Keep it short and to the point. 1.07. What is the ratio of the Primary completion rate (% of total enrollments) in Congo (Republic) in 2007 to that in 2008?
Provide a short and direct response. 1.08. What is the ratio of the Primary completion rate (% of total enrollments) of Marshall Islands in 2007 to that in 2008?
Your response must be concise. 0.98. What is the ratio of the Primary completion rate (% of total enrollments) in Sri Lanka in 2007 to that in 2008?
Ensure brevity in your answer.  1.05. What is the ratio of the Primary completion rate (% of total enrollments) of Zambia in 2007 to that in 2008?
Your answer should be compact. 0.97. What is the ratio of the Primary completion rate (% of total enrollments) of Congo (Republic) in 2007 to that in 2009?
Your response must be concise. 1.09. What is the ratio of the Primary completion rate (% of total enrollments) of Marshall Islands in 2007 to that in 2009?
Your answer should be very brief. 1.06. What is the ratio of the Primary completion rate (% of total enrollments) of Sri Lanka in 2007 to that in 2009?
Offer a terse response. 1.05. What is the ratio of the Primary completion rate (% of total enrollments) of Zambia in 2007 to that in 2009?
Ensure brevity in your answer.  1.04. What is the ratio of the Primary completion rate (% of total enrollments) in Congo (Republic) in 2008 to that in 2009?
Ensure brevity in your answer.  1.01. What is the ratio of the Primary completion rate (% of total enrollments) in Marshall Islands in 2008 to that in 2009?
Your answer should be compact. 1.07. What is the ratio of the Primary completion rate (% of total enrollments) in Zambia in 2008 to that in 2009?
Keep it short and to the point. 1.08. What is the difference between the highest and the second highest Primary completion rate (% of total enrollments) in Congo (Republic)?
Ensure brevity in your answer.  3.15. What is the difference between the highest and the second highest Primary completion rate (% of total enrollments) in Marshall Islands?
Provide a succinct answer. 0.15. What is the difference between the highest and the second highest Primary completion rate (% of total enrollments) of Sri Lanka?
Make the answer very short. 13.44. What is the difference between the highest and the second highest Primary completion rate (% of total enrollments) of Zambia?
Give a very brief answer. 1.05. What is the difference between the highest and the lowest Primary completion rate (% of total enrollments) of Congo (Republic)?
Offer a terse response. 20.58. What is the difference between the highest and the lowest Primary completion rate (% of total enrollments) of Marshall Islands?
Provide a short and direct response. 7.96. What is the difference between the highest and the lowest Primary completion rate (% of total enrollments) in Sri Lanka?
Make the answer very short. 21.62. What is the difference between the highest and the lowest Primary completion rate (% of total enrollments) in Zambia?
Keep it short and to the point. 32.47. 